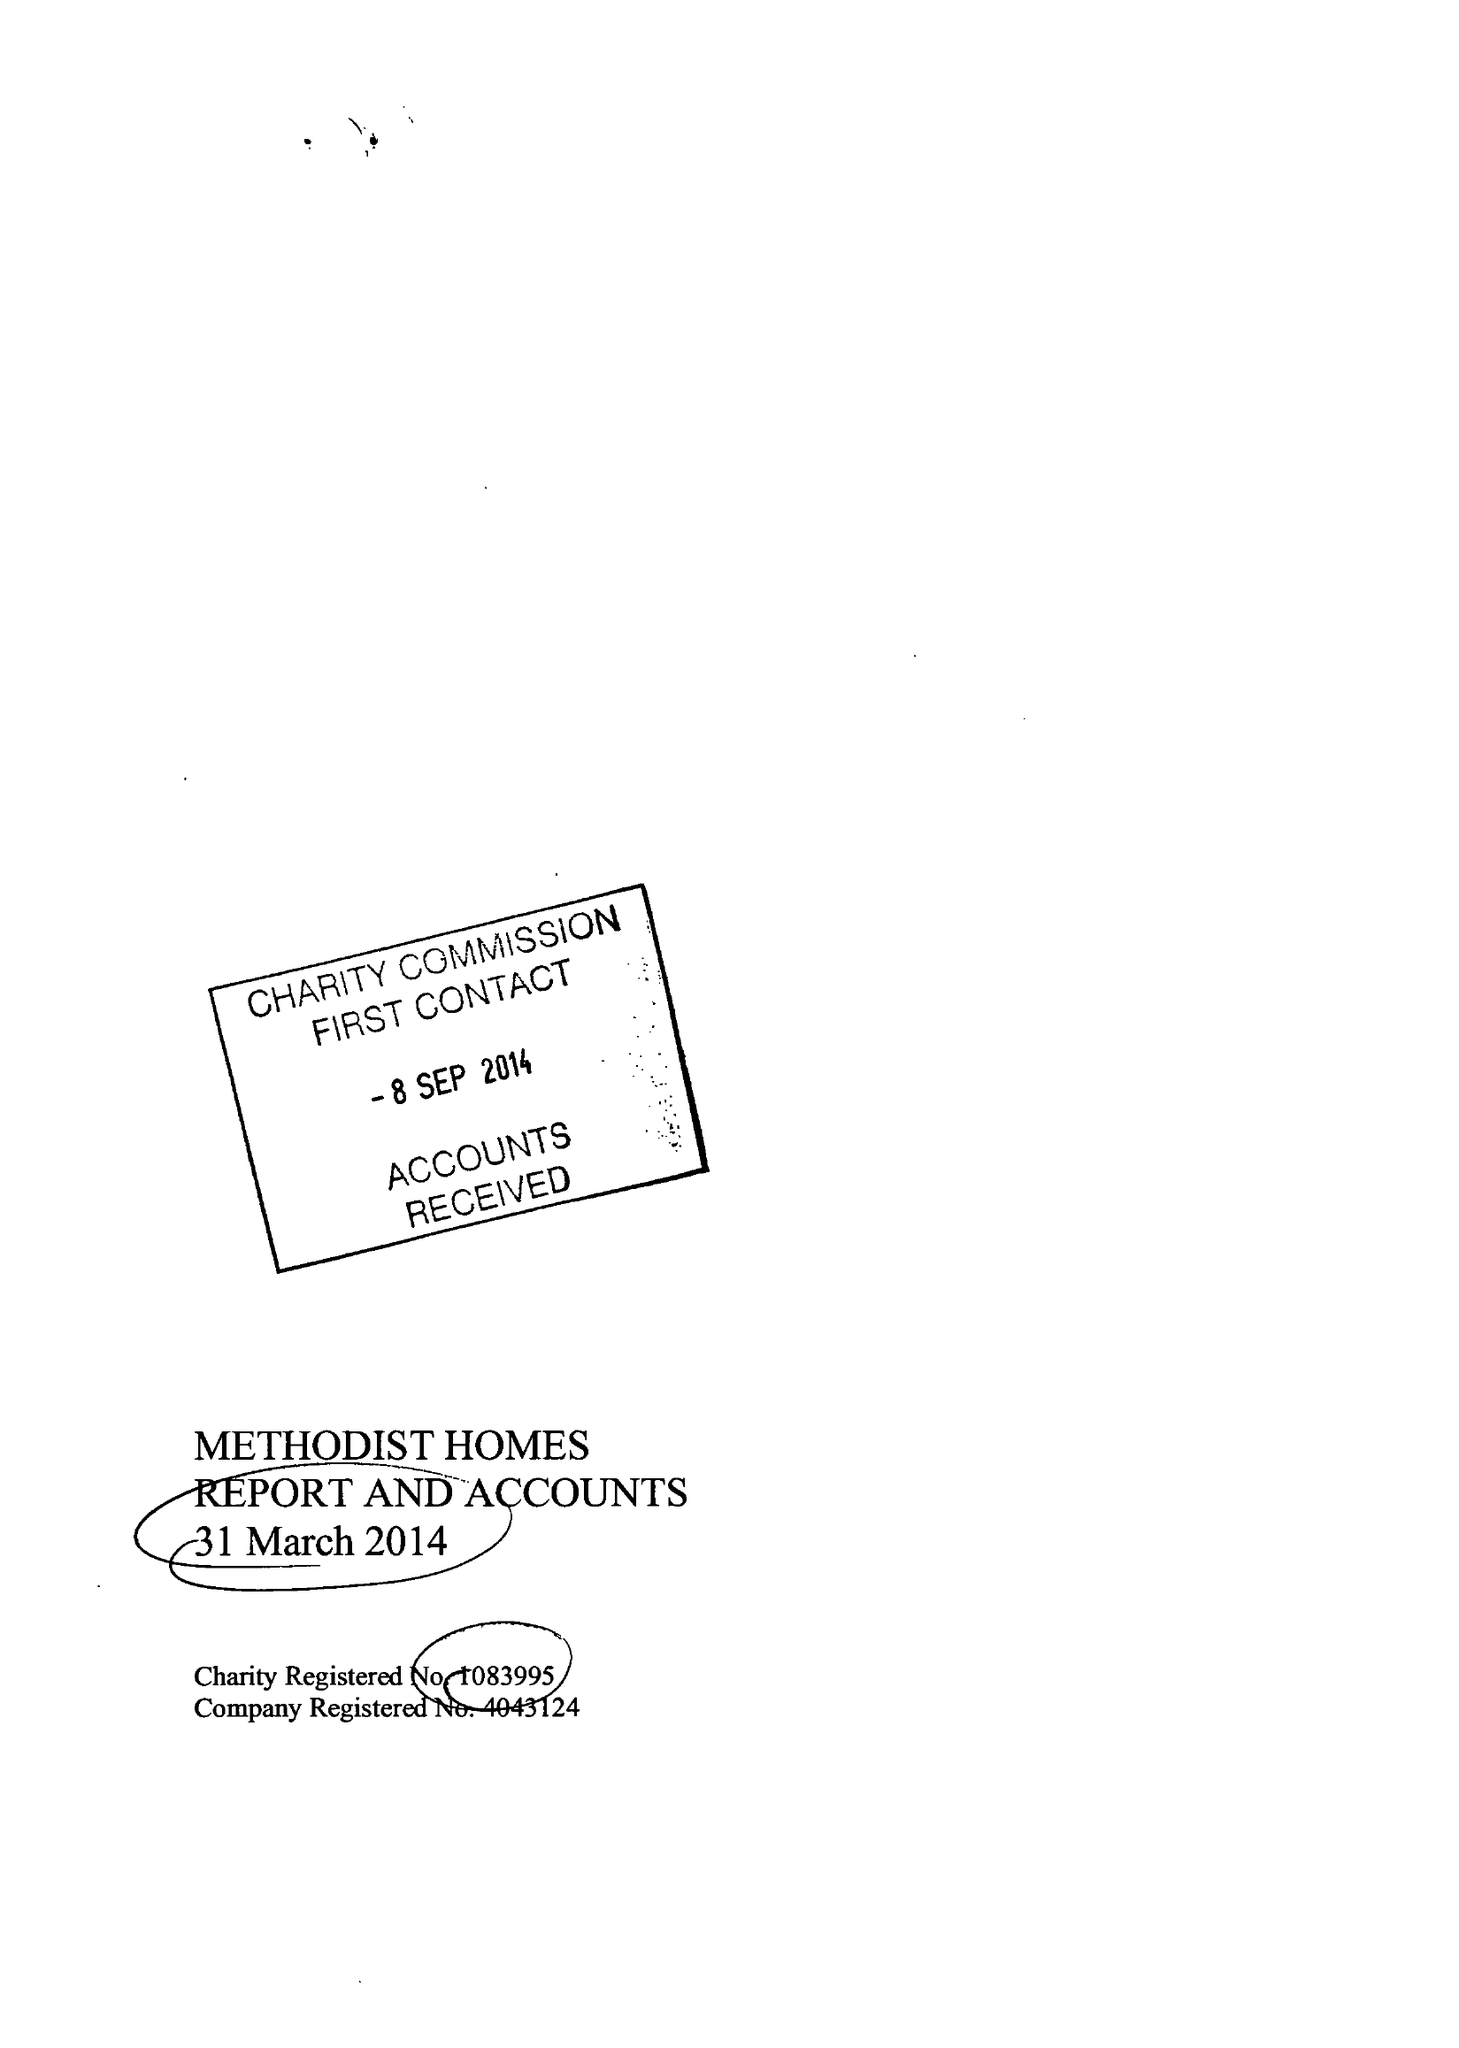What is the value for the address__post_town?
Answer the question using a single word or phrase. DERBY 